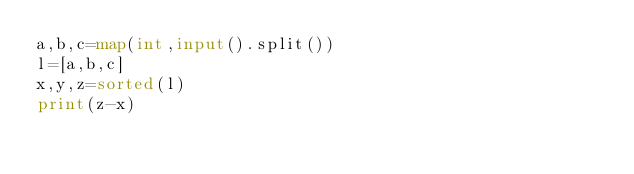<code> <loc_0><loc_0><loc_500><loc_500><_Python_>a,b,c=map(int,input().split())
l=[a,b,c]
x,y,z=sorted(l)
print(z-x)</code> 